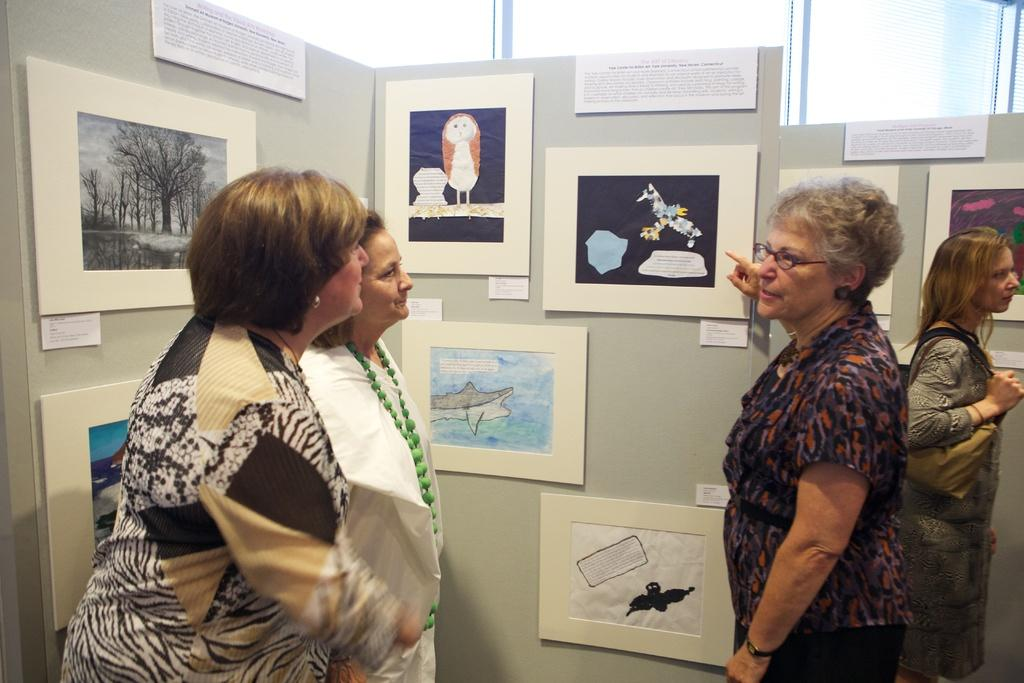Who or what is present in the image? There are people in the image. What can be seen on the walls in the image? There are walls with posters in the image. What is on the boards in the image? There are boards with text and images in the image. What material is visible in the image? There is glass visible in the image. How many balloons are floating above the people in the image? There are no balloons visible in the image. What finger is the person on the left using to point at the poster? There is no person pointing at a poster in the image. 